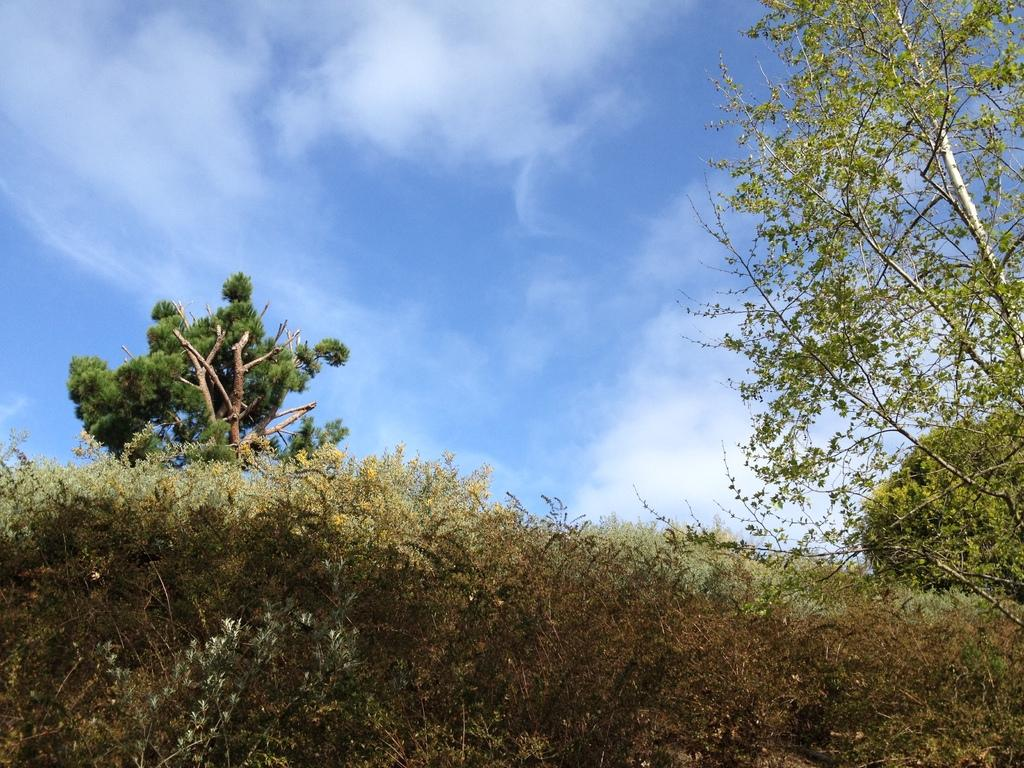What is the primary subject of the image? The primary subject of the image is the many plants. Are there any other objects or structures visible in the image? Yes, there are three trees around the plants. Reasoning: Let'ing: Let's think step by step in order to produce the conversation. We start by identifying the main subject of the image, which is the many plants. Then, we expand the conversation to include other objects that are also visible, such as the three trees. Each question is designed to elicit a specific detail about the image that is known from the provided facts. Absurd Question/Answer: Where is the station located in the image? There is no mention of a station in the image, so it cannot be located. 